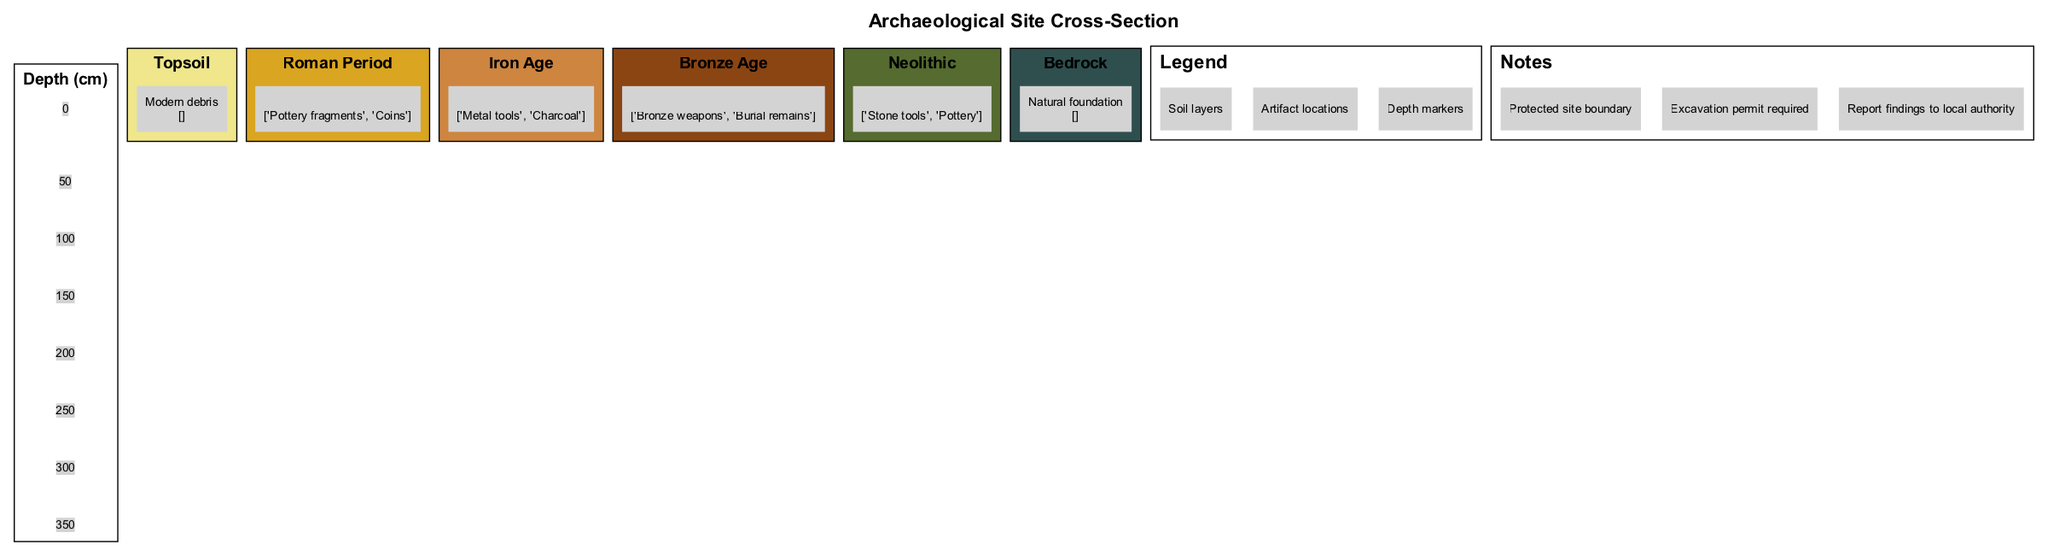What is the depth range of the Topsoil layer? The diagram indicates that the Topsoil layer ranges from 0 to 30 centimeters in depth.
Answer: 0-30 cm What artifacts are found in the Bronze Age layer? In the Bronze Age layer, the artifacts listed are "Bronze weapons" and "Burial remains."
Answer: Bronze weapons, Burial remains How many soil layers are represented in the diagram? By counting the layers listed in the diagram, there are six distinct soil layers presented.
Answer: 6 What is the depth at which the Iron Age layer starts? The Iron Age layer commences at a depth of 100 centimeters, as indicated by its depth range in the diagram.
Answer: 100 cm What is the purpose of the notes section in the diagram? The notes section provides important information regarding site protection, permits for excavation, and reporting findings to local authorities, highlighting regulations necessary for safeguarding archaeological sites.
Answer: Site protection Which layer contains artifacts from the Roman period? The layer specifically containing artifacts from the Roman period is labeled as the "Roman Period" layer.
Answer: Roman Period If excavations are permitted, which authority should findings be reported to? According to the notes section, the findings should be reported to the "local authority."
Answer: local authority Which soil layer is characterized as “natural foundation”? The Bedrock layer is described as the “natural foundation” in the diagram.
Answer: Bedrock What color represents the Iron Age layer in the diagram? The Iron Age layer is represented by a color that corresponds to a specific color code, which is a dark brown shade in the diagram.
Answer: Brown 